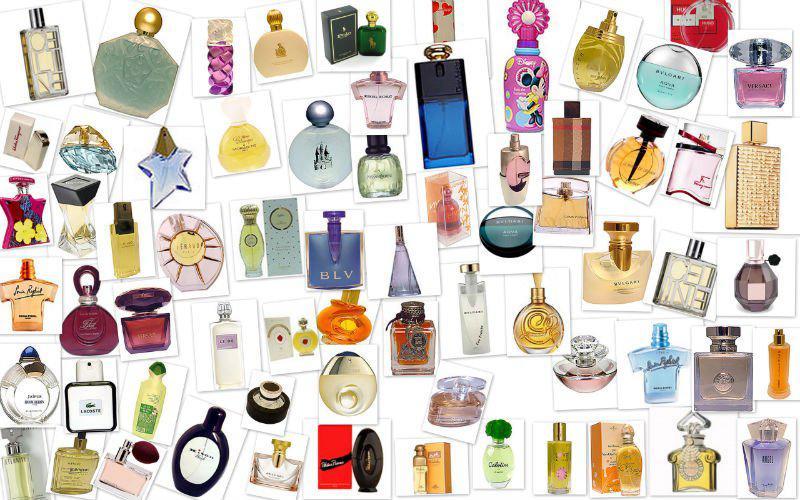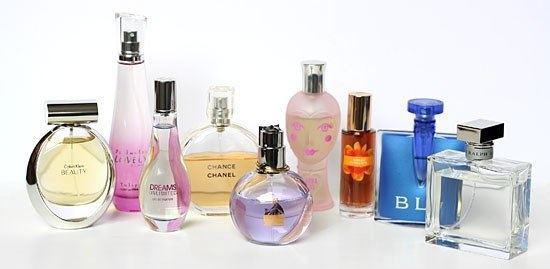The first image is the image on the left, the second image is the image on the right. Evaluate the accuracy of this statement regarding the images: "One of the images shows a corner area of a shop.". Is it true? Answer yes or no. No. The first image is the image on the left, the second image is the image on the right. For the images displayed, is the sentence "There are at most four perfume bottles in the left image." factually correct? Answer yes or no. No. 